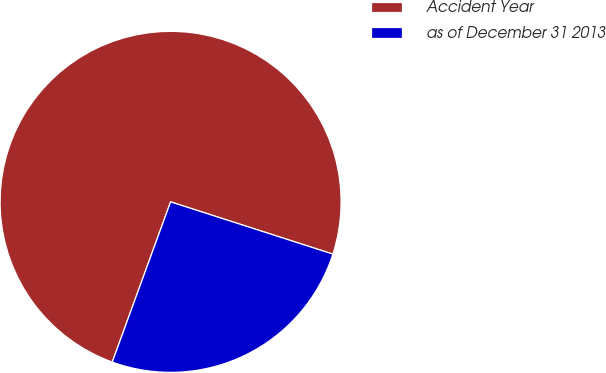<chart> <loc_0><loc_0><loc_500><loc_500><pie_chart><fcel>Accident Year<fcel>as of December 31 2013<nl><fcel>74.4%<fcel>25.6%<nl></chart> 